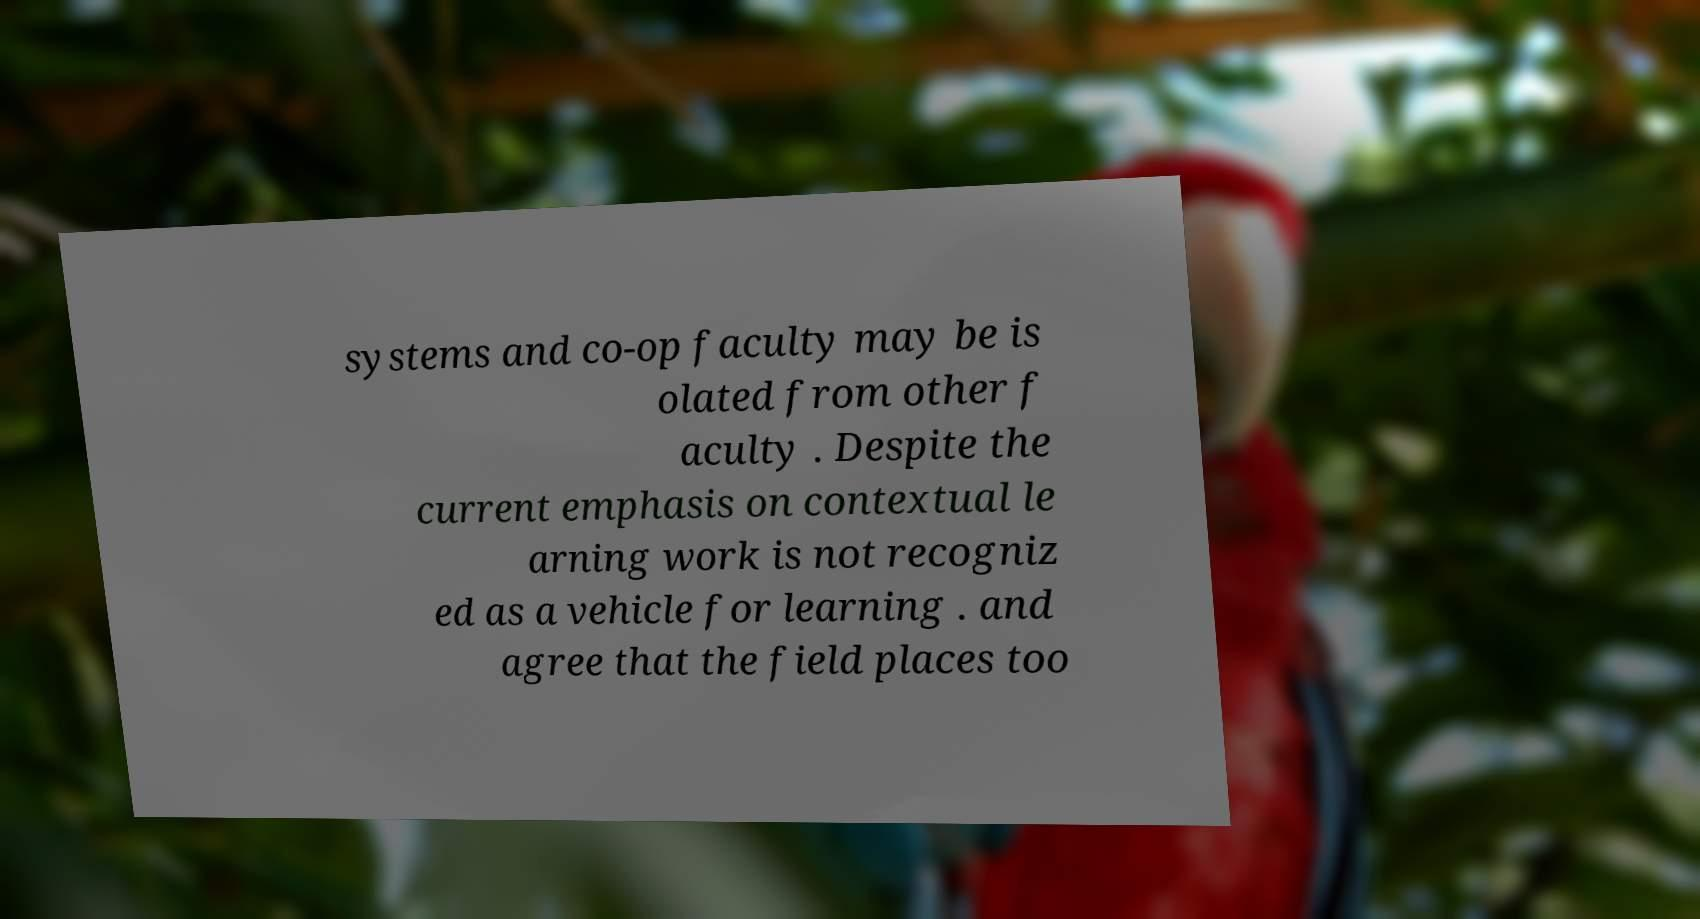I need the written content from this picture converted into text. Can you do that? systems and co-op faculty may be is olated from other f aculty . Despite the current emphasis on contextual le arning work is not recogniz ed as a vehicle for learning . and agree that the field places too 